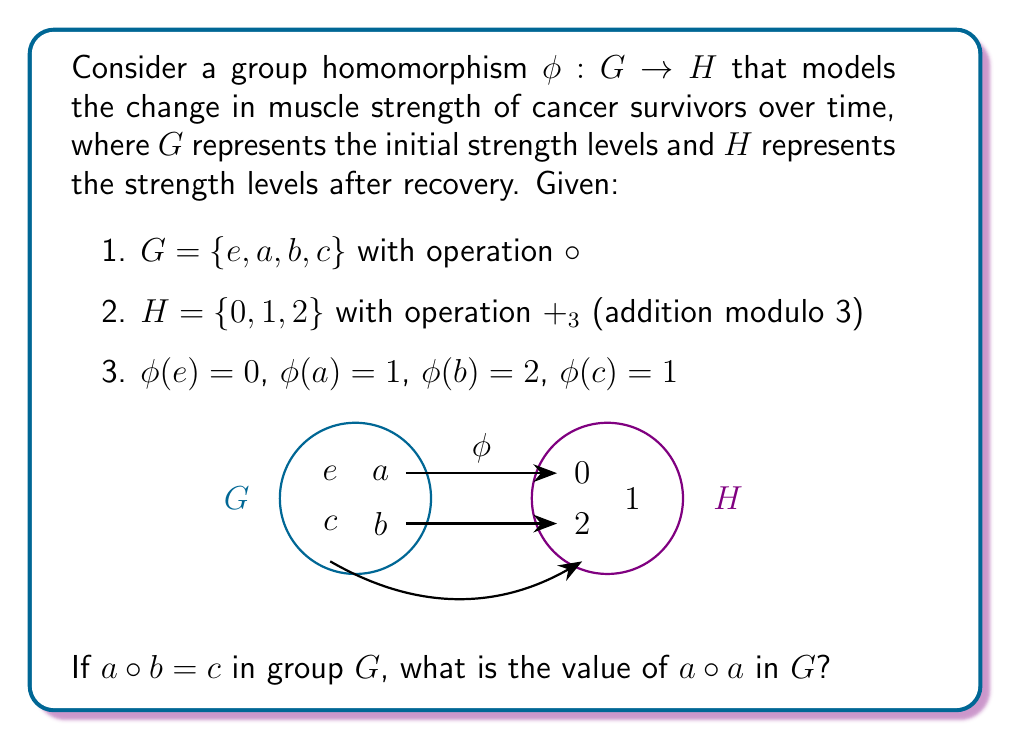What is the answer to this math problem? Let's approach this step-by-step:

1) First, we know that $\phi$ is a group homomorphism, so it must preserve the group operation. This means:

   $\phi(x \circ y) = \phi(x) +_3 \phi(y)$ for all $x, y \in G$

2) We're given that $a \circ b = c$. Applying $\phi$ to both sides:

   $\phi(a \circ b) = \phi(c)$

3) Using the homomorphism property:

   $\phi(a) +_3 \phi(b) = \phi(c)$

4) We know the values of $\phi(a)$, $\phi(b)$, and $\phi(c)$:

   $1 +_3 2 = 1$

5) This equation is true in modulo 3 arithmetic.

6) Now, let's consider $a \circ a$. Applying $\phi$:

   $\phi(a \circ a) = \phi(a) +_3 \phi(a) = 1 +_3 1 = 2$

7) This means that $a \circ a$ must be an element of $G$ that $\phi$ maps to 2.

8) From the given information, we see that $\phi(b) = 2$.

9) Therefore, $a \circ a = b$ in group $G$.
Answer: $b$ 